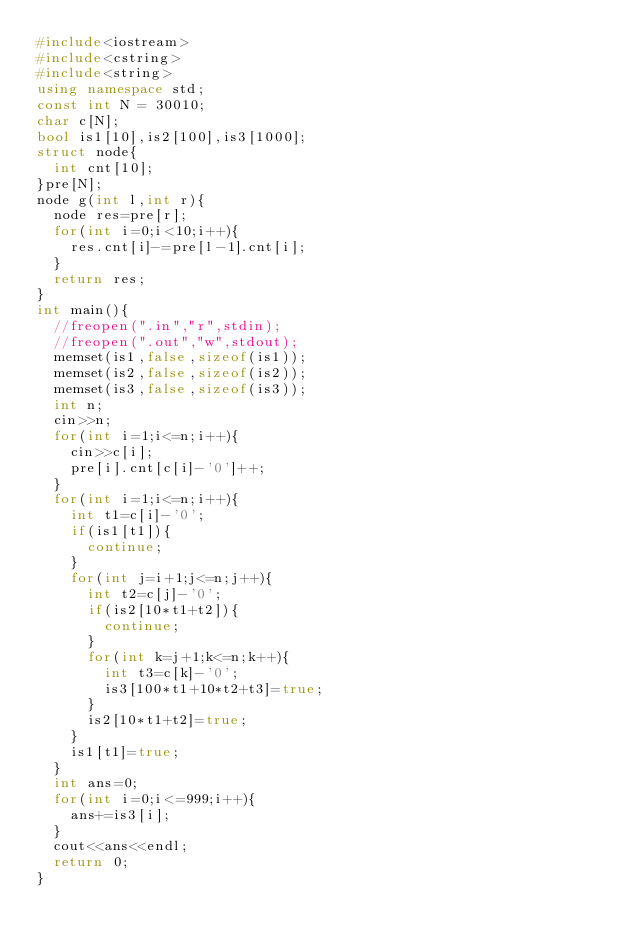Convert code to text. <code><loc_0><loc_0><loc_500><loc_500><_C++_>#include<iostream>
#include<cstring>
#include<string>
using namespace std;
const int N = 30010;
char c[N];
bool is1[10],is2[100],is3[1000];
struct node{
	int cnt[10];
}pre[N];
node g(int l,int r){
	node res=pre[r];
	for(int i=0;i<10;i++){
		res.cnt[i]-=pre[l-1].cnt[i];
	}
	return res;
}
int main(){
	//freopen(".in","r",stdin);
	//freopen(".out","w",stdout);
	memset(is1,false,sizeof(is1));
	memset(is2,false,sizeof(is2));
	memset(is3,false,sizeof(is3));
	int n;
	cin>>n;
	for(int i=1;i<=n;i++){
		cin>>c[i];
		pre[i].cnt[c[i]-'0']++;
	}
	for(int i=1;i<=n;i++){
		int t1=c[i]-'0';
		if(is1[t1]){
			continue;
		}
		for(int j=i+1;j<=n;j++){
			int t2=c[j]-'0';
			if(is2[10*t1+t2]){
				continue;
			}
			for(int k=j+1;k<=n;k++){
				int t3=c[k]-'0';
				is3[100*t1+10*t2+t3]=true;
			}
			is2[10*t1+t2]=true;
		}
		is1[t1]=true;
	}
	int ans=0;
	for(int i=0;i<=999;i++){
		ans+=is3[i];
	}
	cout<<ans<<endl;
	return 0;
}</code> 